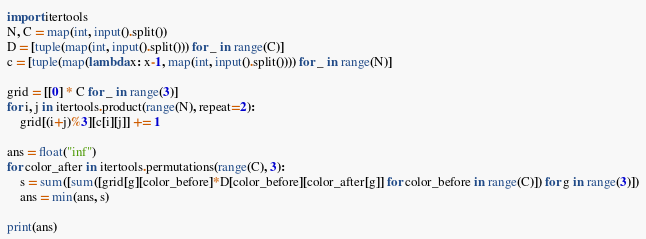<code> <loc_0><loc_0><loc_500><loc_500><_Python_>import itertools
N, C = map(int, input().split())
D = [tuple(map(int, input().split())) for _ in range(C)]
c = [tuple(map(lambda x: x-1, map(int, input().split()))) for _ in range(N)]

grid = [[0] * C for _ in range(3)]
for i, j in itertools.product(range(N), repeat=2):
    grid[(i+j)%3][c[i][j]] += 1

ans = float("inf")
for color_after in itertools.permutations(range(C), 3):
    s = sum([sum([grid[g][color_before]*D[color_before][color_after[g]] for color_before in range(C)]) for g in range(3)])
    ans = min(ans, s)

print(ans)
</code> 